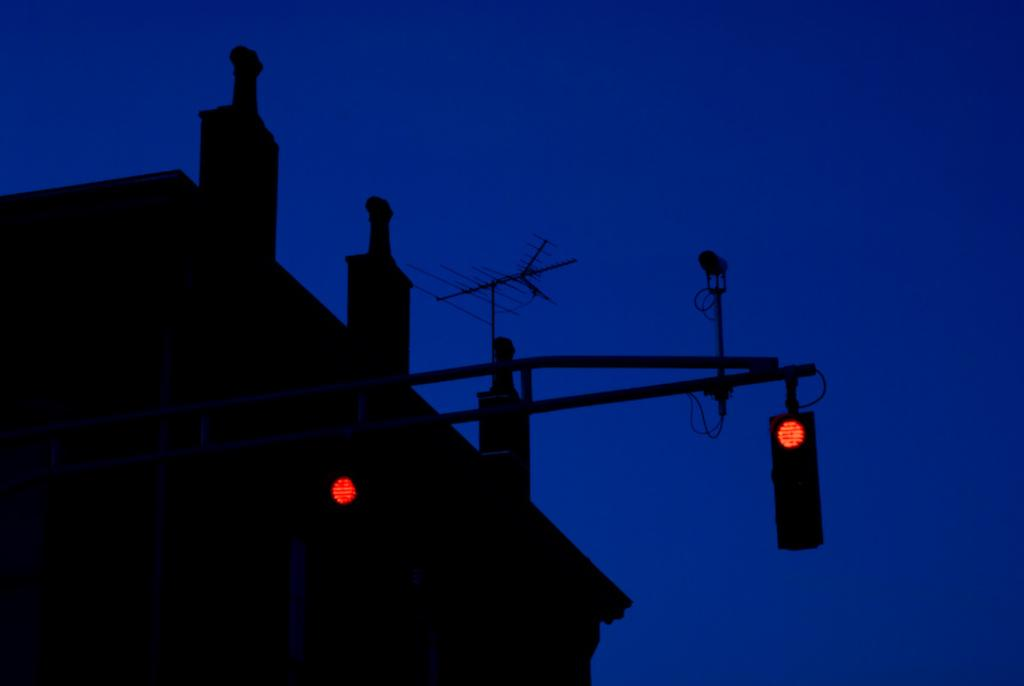What type of signaling device is present in the image? There are traffic lights in the image. What structure is located on the left side of the image? There is a building on the left side of the image. What type of communication device is visible in the image? There is an antenna visible in the image. What is visible at the top of the image? The sky is visible at the top of the image. How many clocks are present in the image? There are no clocks visible in the image. What type of home is shown in the image? There is no home present in the image; it features a building and traffic lights. 